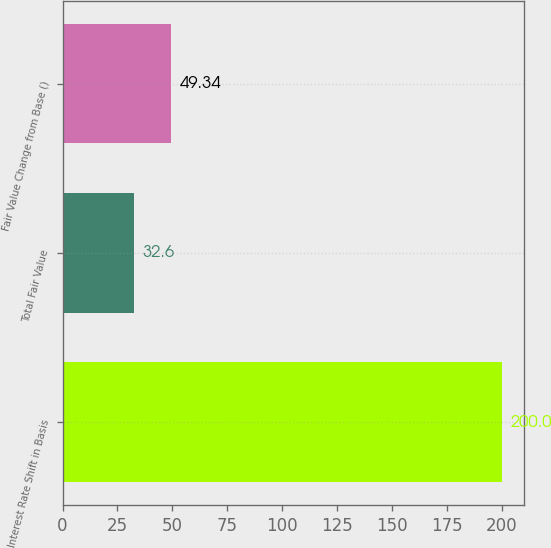Convert chart to OTSL. <chart><loc_0><loc_0><loc_500><loc_500><bar_chart><fcel>Interest Rate Shift in Basis<fcel>Total Fair Value<fcel>Fair Value Change from Base ()<nl><fcel>200<fcel>32.6<fcel>49.34<nl></chart> 